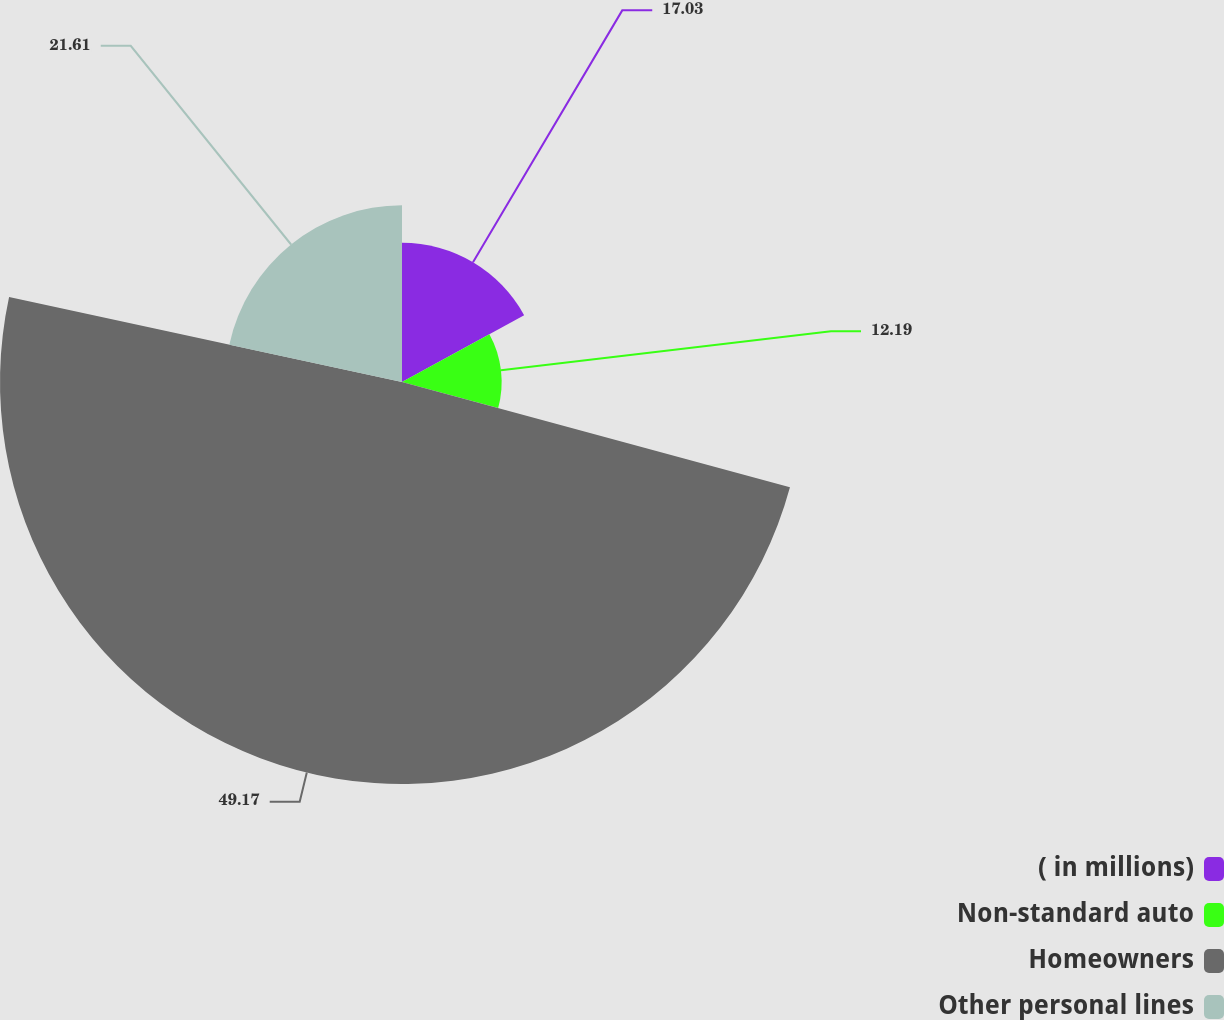<chart> <loc_0><loc_0><loc_500><loc_500><pie_chart><fcel>( in millions)<fcel>Non-standard auto<fcel>Homeowners<fcel>Other personal lines<nl><fcel>17.03%<fcel>12.19%<fcel>49.17%<fcel>21.61%<nl></chart> 